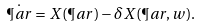Convert formula to latex. <formula><loc_0><loc_0><loc_500><loc_500>\dot { \P a r } = X ( \P a r ) - \delta X ( \P a r , w ) .</formula> 